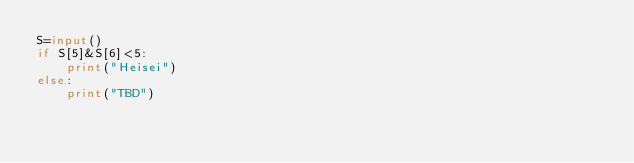Convert code to text. <code><loc_0><loc_0><loc_500><loc_500><_Python_>S=input()
if S[5]&S[6]<5:
	print("Heisei")
else:
	print("TBD")
</code> 